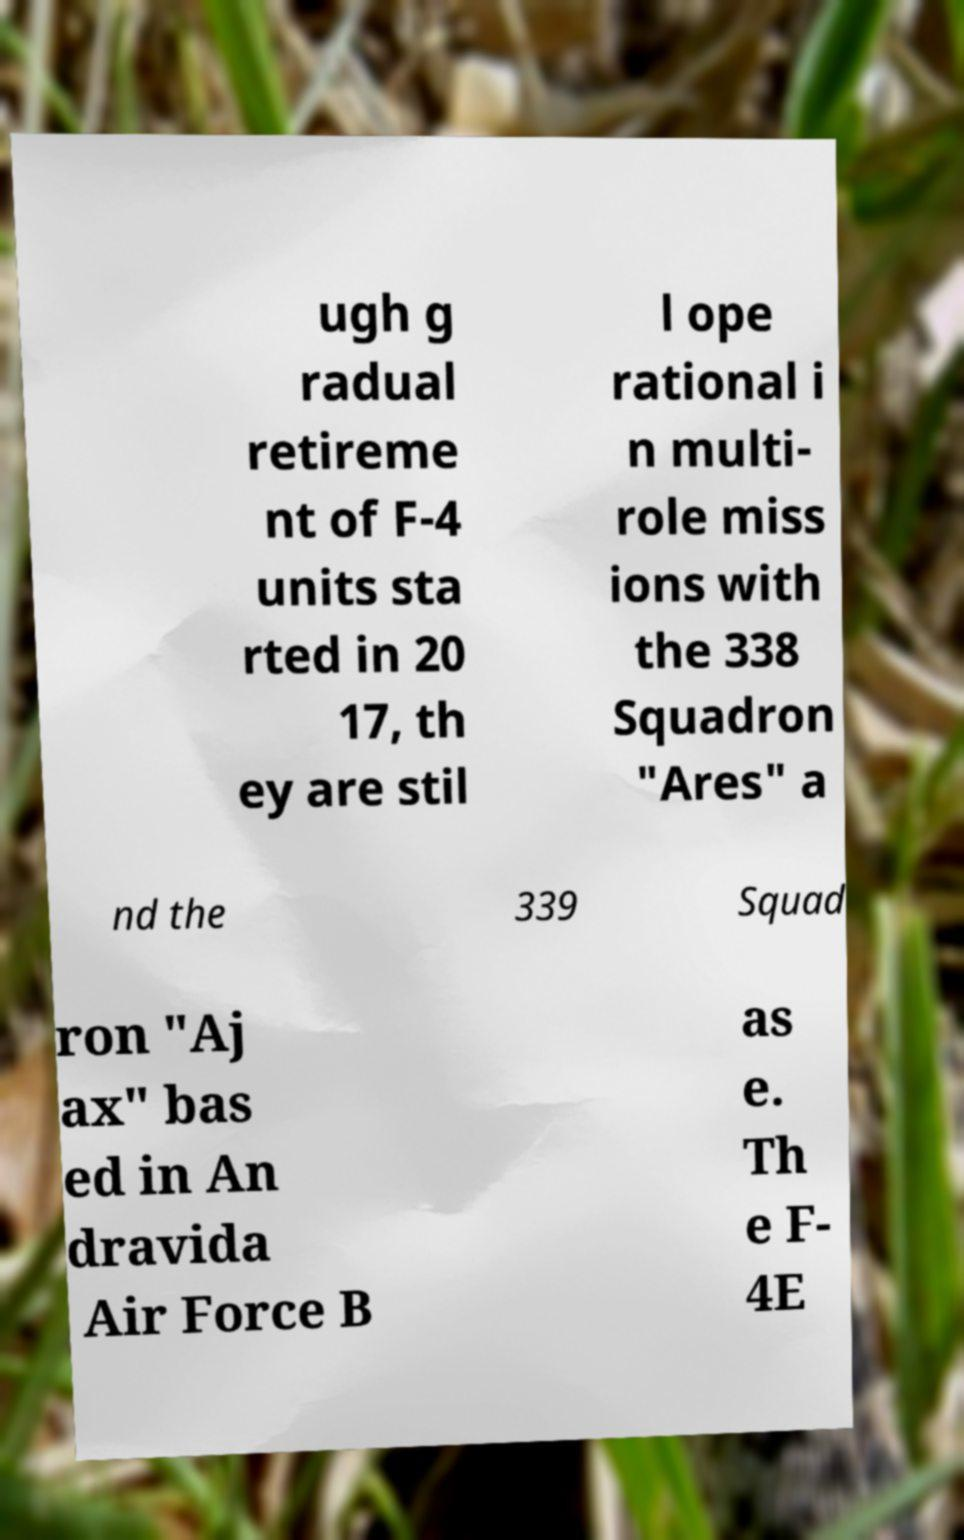Can you accurately transcribe the text from the provided image for me? ugh g radual retireme nt of F-4 units sta rted in 20 17, th ey are stil l ope rational i n multi- role miss ions with the 338 Squadron "Ares" a nd the 339 Squad ron "Aj ax" bas ed in An dravida Air Force B as e. Th e F- 4E 